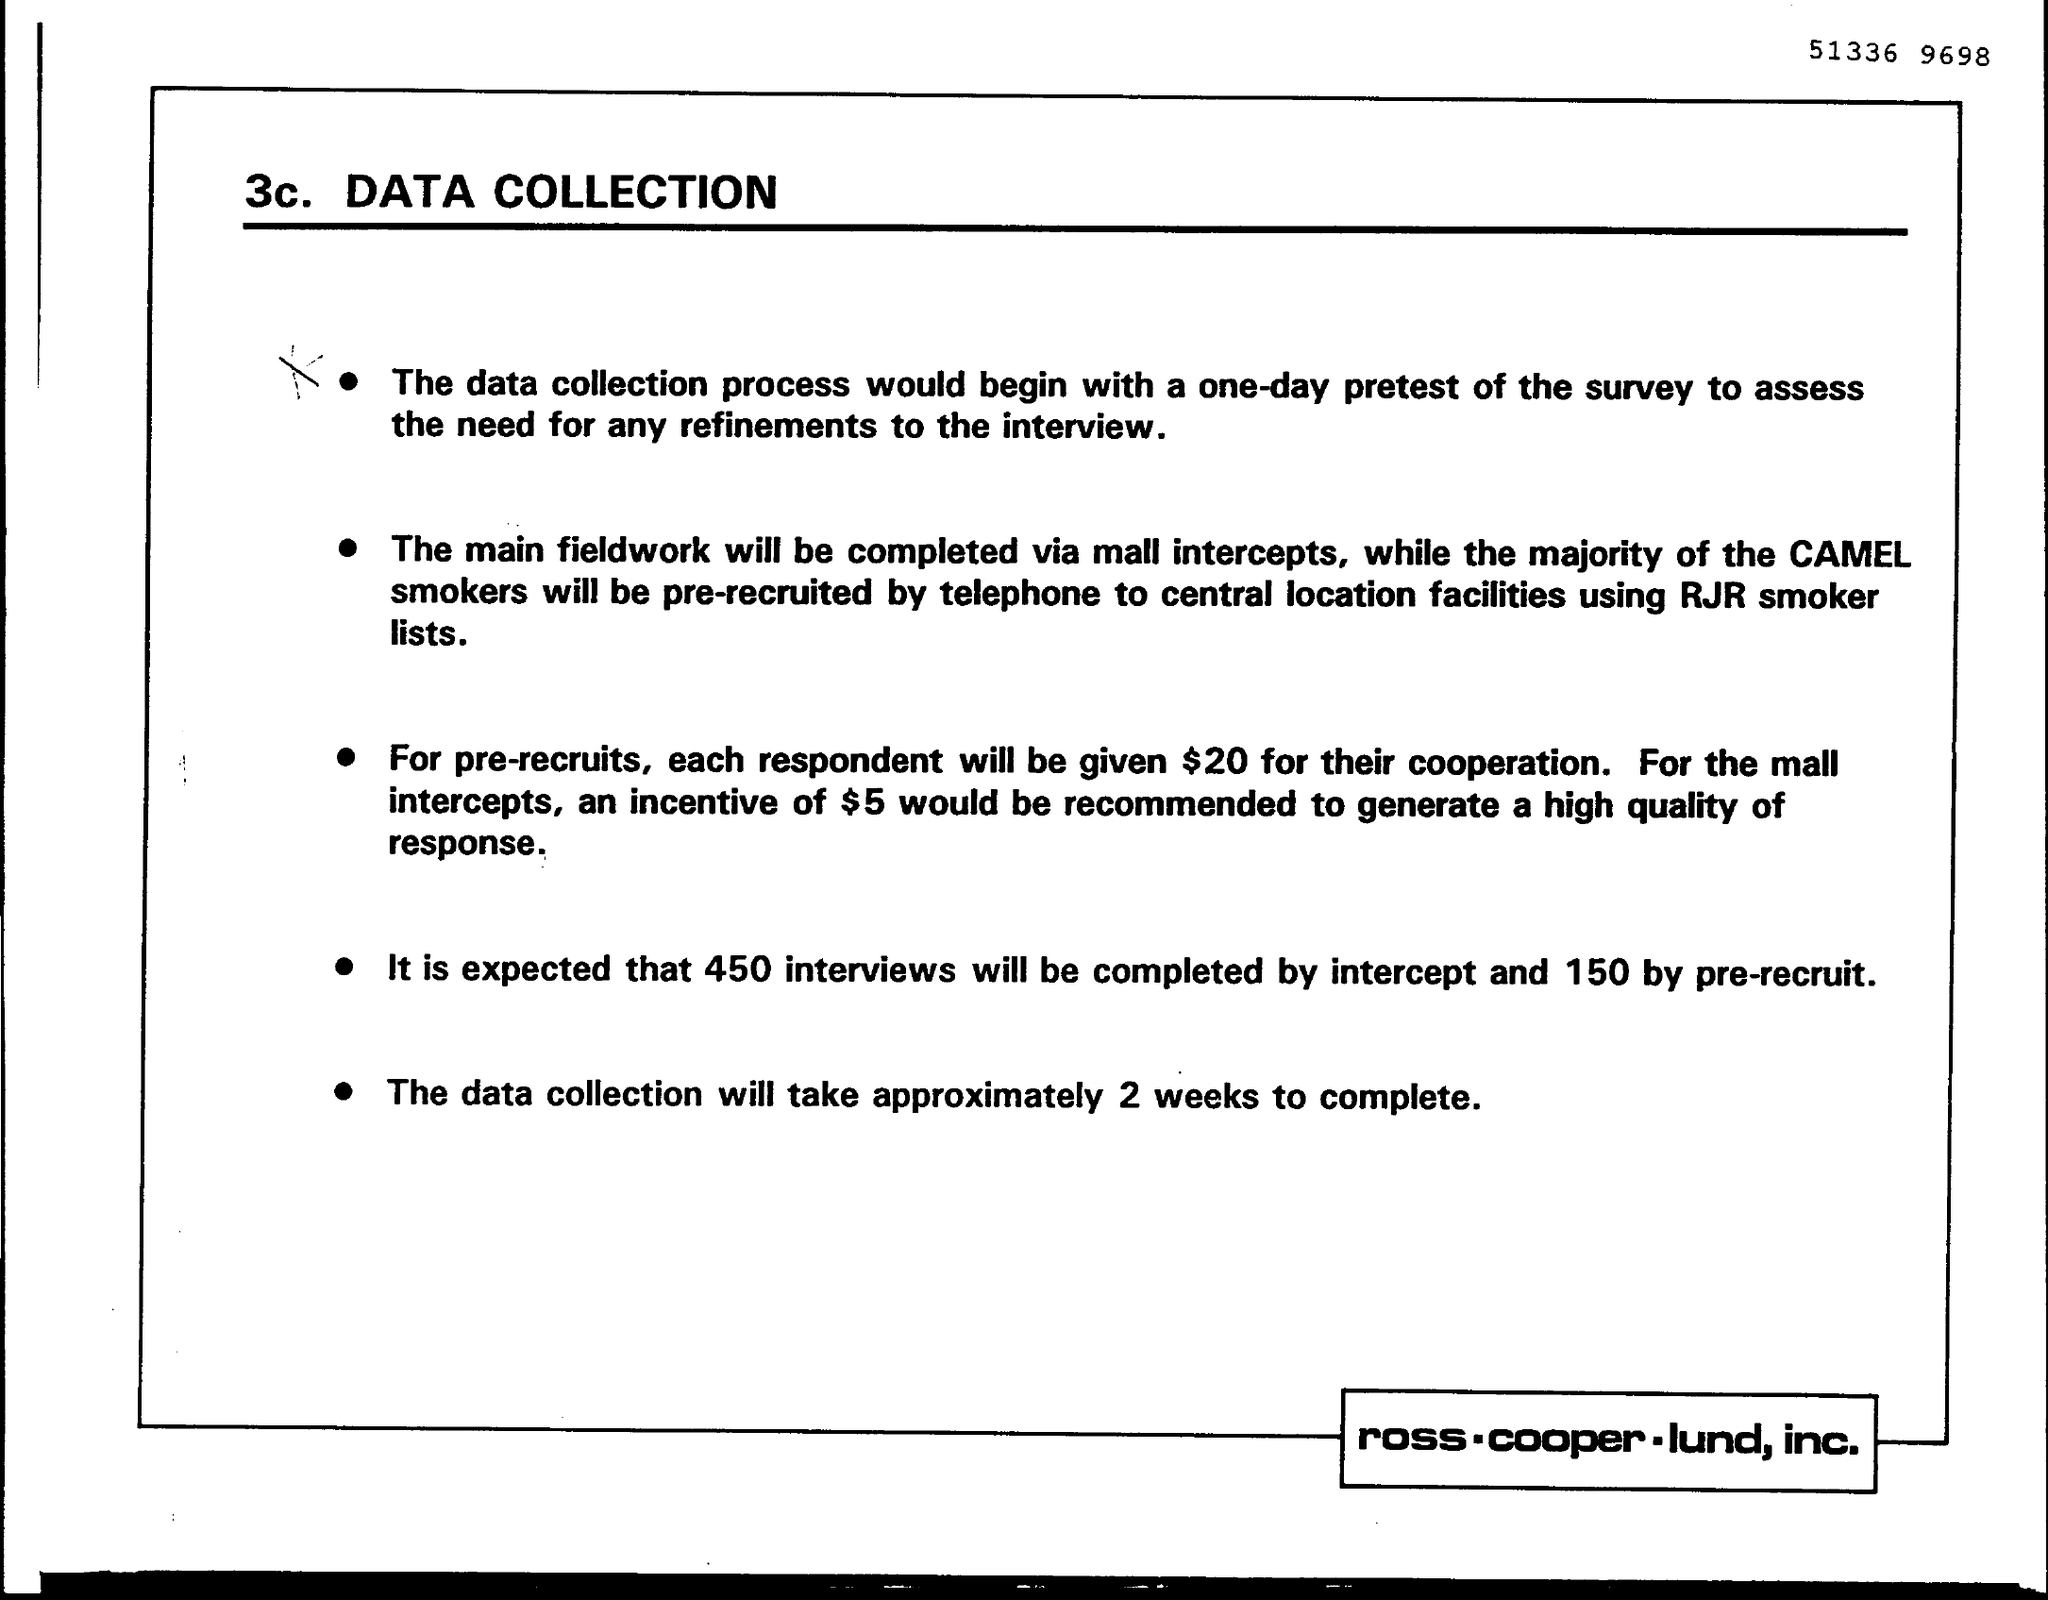How many interviews will be completed ?
Ensure brevity in your answer.  450. 